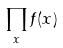<formula> <loc_0><loc_0><loc_500><loc_500>\prod _ { x } f ( x )</formula> 